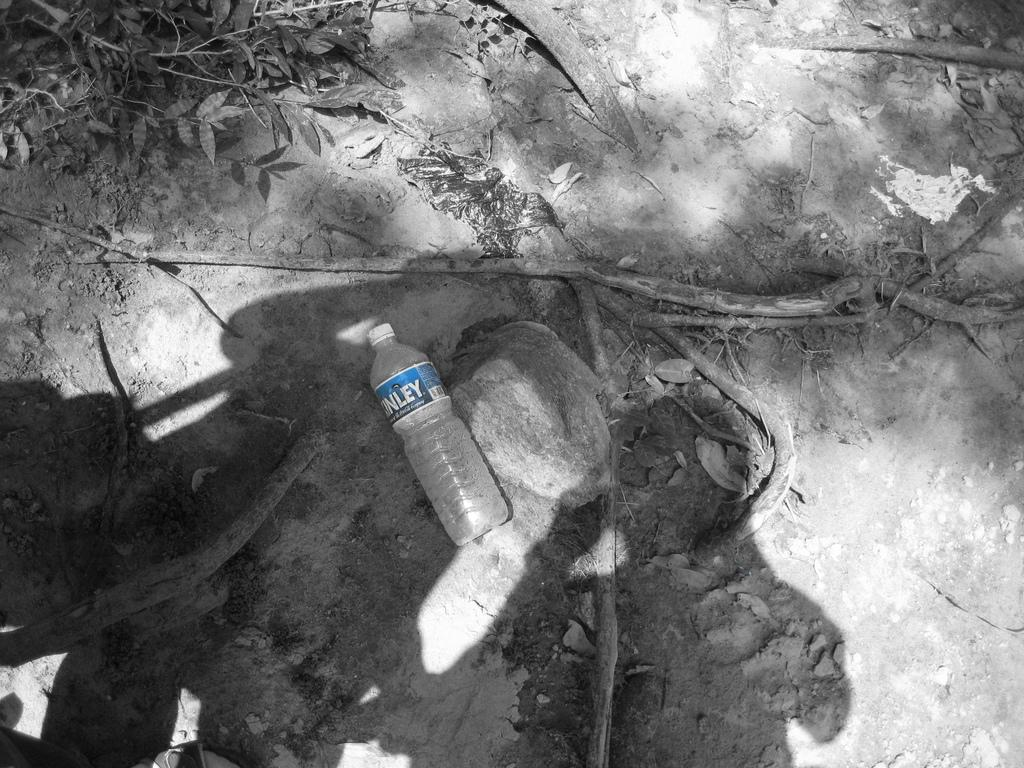What object is placed on the floor in the image? There is a bottle on the floor in the image. What color is the cap of the bottle? The bottle has a white-colored cap. What can be seen on the left side of the image? There are leaves on the left side of the image. What type of cast can be seen on the person's arm in the image? There is no person or cast present in the image; it only features a bottle with a white-colored cap and leaves on the left side. 